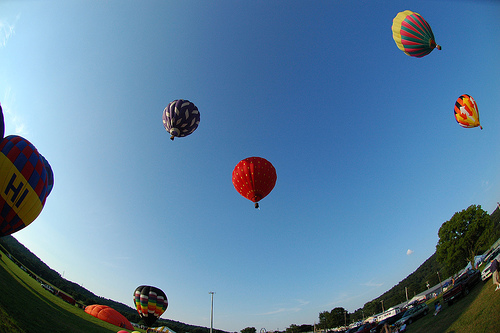<image>
Is the balloon in front of the sky? No. The balloon is not in front of the sky. The spatial positioning shows a different relationship between these objects. 